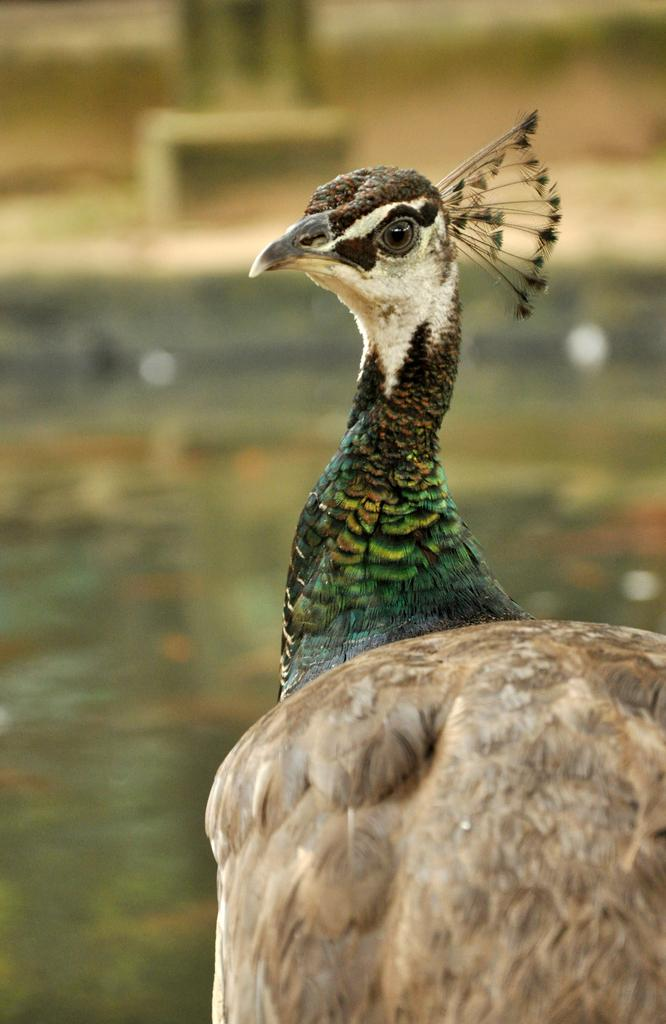What type of animal is in the image? There is a bird in the image. Can you describe the bird's colors? The bird has brown, cream, green, and black colors. How would you describe the background of the image? The background of the image is blurry. What type of horn does the boy in the image have? There is no boy present in the image, only a bird. What color is the crayon being used by the bird in the image? There is no crayon present in the image; the bird is not depicted using any writing or drawing tools. 